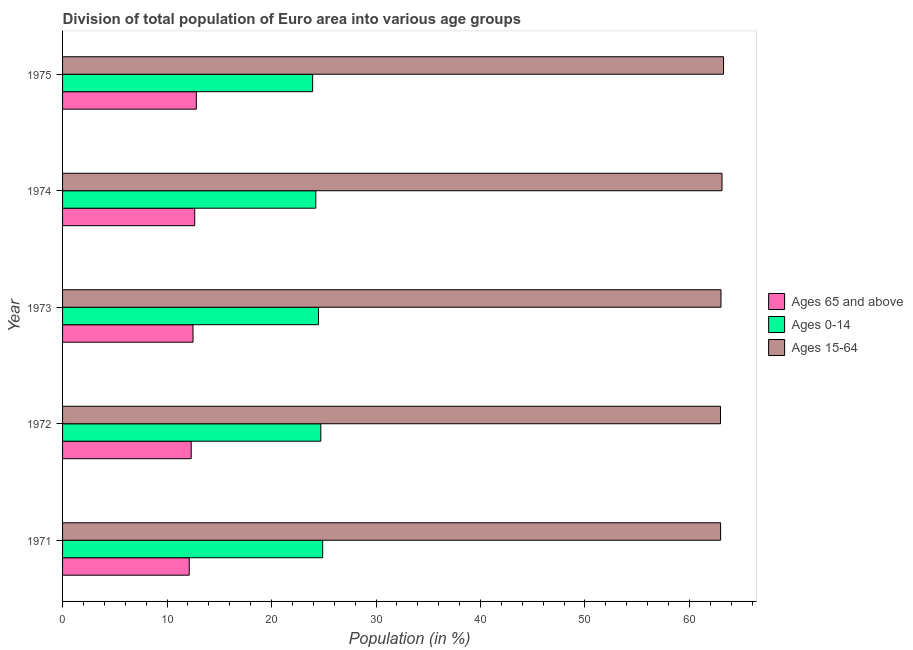How many groups of bars are there?
Ensure brevity in your answer.  5. Are the number of bars per tick equal to the number of legend labels?
Provide a succinct answer. Yes. Are the number of bars on each tick of the Y-axis equal?
Your answer should be very brief. Yes. How many bars are there on the 3rd tick from the bottom?
Your answer should be very brief. 3. What is the label of the 2nd group of bars from the top?
Give a very brief answer. 1974. In how many cases, is the number of bars for a given year not equal to the number of legend labels?
Your answer should be compact. 0. What is the percentage of population within the age-group 0-14 in 1974?
Give a very brief answer. 24.24. Across all years, what is the maximum percentage of population within the age-group 15-64?
Offer a very short reply. 63.26. Across all years, what is the minimum percentage of population within the age-group 0-14?
Make the answer very short. 23.93. In which year was the percentage of population within the age-group 15-64 minimum?
Ensure brevity in your answer.  1972. What is the total percentage of population within the age-group of 65 and above in the graph?
Your response must be concise. 62.37. What is the difference between the percentage of population within the age-group 15-64 in 1972 and that in 1974?
Ensure brevity in your answer.  -0.14. What is the difference between the percentage of population within the age-group 15-64 in 1972 and the percentage of population within the age-group of 65 and above in 1971?
Give a very brief answer. 50.85. What is the average percentage of population within the age-group 0-14 per year?
Offer a terse response. 24.46. In the year 1971, what is the difference between the percentage of population within the age-group 0-14 and percentage of population within the age-group of 65 and above?
Your answer should be very brief. 12.77. What is the ratio of the percentage of population within the age-group of 65 and above in 1973 to that in 1974?
Keep it short and to the point. 0.99. Is the difference between the percentage of population within the age-group 0-14 in 1971 and 1973 greater than the difference between the percentage of population within the age-group 15-64 in 1971 and 1973?
Give a very brief answer. Yes. What is the difference between the highest and the second highest percentage of population within the age-group of 65 and above?
Offer a terse response. 0.15. What is the difference between the highest and the lowest percentage of population within the age-group of 65 and above?
Give a very brief answer. 0.68. In how many years, is the percentage of population within the age-group 15-64 greater than the average percentage of population within the age-group 15-64 taken over all years?
Offer a terse response. 2. What does the 2nd bar from the top in 1974 represents?
Make the answer very short. Ages 0-14. What does the 2nd bar from the bottom in 1971 represents?
Give a very brief answer. Ages 0-14. Is it the case that in every year, the sum of the percentage of population within the age-group of 65 and above and percentage of population within the age-group 0-14 is greater than the percentage of population within the age-group 15-64?
Your answer should be very brief. No. How many years are there in the graph?
Your answer should be very brief. 5. How are the legend labels stacked?
Provide a succinct answer. Vertical. What is the title of the graph?
Ensure brevity in your answer.  Division of total population of Euro area into various age groups
. Does "Taxes on international trade" appear as one of the legend labels in the graph?
Make the answer very short. No. What is the label or title of the Y-axis?
Ensure brevity in your answer.  Year. What is the Population (in %) in Ages 65 and above in 1971?
Your answer should be very brief. 12.12. What is the Population (in %) in Ages 0-14 in 1971?
Provide a succinct answer. 24.9. What is the Population (in %) in Ages 15-64 in 1971?
Your answer should be compact. 62.98. What is the Population (in %) of Ages 65 and above in 1972?
Give a very brief answer. 12.31. What is the Population (in %) of Ages 0-14 in 1972?
Offer a very short reply. 24.72. What is the Population (in %) of Ages 15-64 in 1972?
Offer a very short reply. 62.97. What is the Population (in %) in Ages 65 and above in 1973?
Keep it short and to the point. 12.49. What is the Population (in %) of Ages 0-14 in 1973?
Your answer should be very brief. 24.5. What is the Population (in %) in Ages 15-64 in 1973?
Your answer should be compact. 63.02. What is the Population (in %) in Ages 65 and above in 1974?
Offer a very short reply. 12.65. What is the Population (in %) of Ages 0-14 in 1974?
Provide a succinct answer. 24.24. What is the Population (in %) in Ages 15-64 in 1974?
Ensure brevity in your answer.  63.11. What is the Population (in %) in Ages 65 and above in 1975?
Your answer should be very brief. 12.8. What is the Population (in %) in Ages 0-14 in 1975?
Your response must be concise. 23.93. What is the Population (in %) in Ages 15-64 in 1975?
Make the answer very short. 63.26. Across all years, what is the maximum Population (in %) in Ages 65 and above?
Offer a terse response. 12.8. Across all years, what is the maximum Population (in %) in Ages 0-14?
Provide a succinct answer. 24.9. Across all years, what is the maximum Population (in %) in Ages 15-64?
Ensure brevity in your answer.  63.26. Across all years, what is the minimum Population (in %) in Ages 65 and above?
Your answer should be compact. 12.12. Across all years, what is the minimum Population (in %) of Ages 0-14?
Ensure brevity in your answer.  23.93. Across all years, what is the minimum Population (in %) of Ages 15-64?
Ensure brevity in your answer.  62.97. What is the total Population (in %) of Ages 65 and above in the graph?
Your response must be concise. 62.37. What is the total Population (in %) in Ages 0-14 in the graph?
Your answer should be very brief. 122.28. What is the total Population (in %) of Ages 15-64 in the graph?
Provide a succinct answer. 315.35. What is the difference between the Population (in %) of Ages 65 and above in 1971 and that in 1972?
Offer a very short reply. -0.19. What is the difference between the Population (in %) in Ages 0-14 in 1971 and that in 1972?
Ensure brevity in your answer.  0.18. What is the difference between the Population (in %) in Ages 15-64 in 1971 and that in 1972?
Your response must be concise. 0.01. What is the difference between the Population (in %) in Ages 65 and above in 1971 and that in 1973?
Ensure brevity in your answer.  -0.36. What is the difference between the Population (in %) of Ages 0-14 in 1971 and that in 1973?
Provide a short and direct response. 0.4. What is the difference between the Population (in %) in Ages 15-64 in 1971 and that in 1973?
Ensure brevity in your answer.  -0.04. What is the difference between the Population (in %) of Ages 65 and above in 1971 and that in 1974?
Provide a short and direct response. -0.52. What is the difference between the Population (in %) of Ages 0-14 in 1971 and that in 1974?
Keep it short and to the point. 0.66. What is the difference between the Population (in %) in Ages 15-64 in 1971 and that in 1974?
Ensure brevity in your answer.  -0.13. What is the difference between the Population (in %) of Ages 65 and above in 1971 and that in 1975?
Offer a terse response. -0.68. What is the difference between the Population (in %) of Ages 0-14 in 1971 and that in 1975?
Offer a terse response. 0.96. What is the difference between the Population (in %) in Ages 15-64 in 1971 and that in 1975?
Your response must be concise. -0.28. What is the difference between the Population (in %) of Ages 65 and above in 1972 and that in 1973?
Keep it short and to the point. -0.17. What is the difference between the Population (in %) of Ages 0-14 in 1972 and that in 1973?
Ensure brevity in your answer.  0.22. What is the difference between the Population (in %) in Ages 15-64 in 1972 and that in 1973?
Provide a short and direct response. -0.05. What is the difference between the Population (in %) of Ages 65 and above in 1972 and that in 1974?
Offer a terse response. -0.34. What is the difference between the Population (in %) of Ages 0-14 in 1972 and that in 1974?
Your answer should be very brief. 0.48. What is the difference between the Population (in %) in Ages 15-64 in 1972 and that in 1974?
Your answer should be compact. -0.14. What is the difference between the Population (in %) in Ages 65 and above in 1972 and that in 1975?
Provide a short and direct response. -0.49. What is the difference between the Population (in %) of Ages 0-14 in 1972 and that in 1975?
Your response must be concise. 0.78. What is the difference between the Population (in %) in Ages 15-64 in 1972 and that in 1975?
Provide a succinct answer. -0.29. What is the difference between the Population (in %) in Ages 65 and above in 1973 and that in 1974?
Your response must be concise. -0.16. What is the difference between the Population (in %) in Ages 0-14 in 1973 and that in 1974?
Offer a terse response. 0.26. What is the difference between the Population (in %) of Ages 15-64 in 1973 and that in 1974?
Ensure brevity in your answer.  -0.1. What is the difference between the Population (in %) in Ages 65 and above in 1973 and that in 1975?
Your answer should be compact. -0.32. What is the difference between the Population (in %) in Ages 0-14 in 1973 and that in 1975?
Offer a terse response. 0.56. What is the difference between the Population (in %) of Ages 15-64 in 1973 and that in 1975?
Give a very brief answer. -0.25. What is the difference between the Population (in %) in Ages 65 and above in 1974 and that in 1975?
Provide a succinct answer. -0.15. What is the difference between the Population (in %) in Ages 0-14 in 1974 and that in 1975?
Offer a terse response. 0.3. What is the difference between the Population (in %) of Ages 15-64 in 1974 and that in 1975?
Keep it short and to the point. -0.15. What is the difference between the Population (in %) of Ages 65 and above in 1971 and the Population (in %) of Ages 0-14 in 1972?
Give a very brief answer. -12.59. What is the difference between the Population (in %) of Ages 65 and above in 1971 and the Population (in %) of Ages 15-64 in 1972?
Provide a short and direct response. -50.85. What is the difference between the Population (in %) of Ages 0-14 in 1971 and the Population (in %) of Ages 15-64 in 1972?
Provide a succinct answer. -38.08. What is the difference between the Population (in %) in Ages 65 and above in 1971 and the Population (in %) in Ages 0-14 in 1973?
Make the answer very short. -12.37. What is the difference between the Population (in %) of Ages 65 and above in 1971 and the Population (in %) of Ages 15-64 in 1973?
Keep it short and to the point. -50.89. What is the difference between the Population (in %) in Ages 0-14 in 1971 and the Population (in %) in Ages 15-64 in 1973?
Make the answer very short. -38.12. What is the difference between the Population (in %) of Ages 65 and above in 1971 and the Population (in %) of Ages 0-14 in 1974?
Your response must be concise. -12.11. What is the difference between the Population (in %) in Ages 65 and above in 1971 and the Population (in %) in Ages 15-64 in 1974?
Your answer should be very brief. -50.99. What is the difference between the Population (in %) of Ages 0-14 in 1971 and the Population (in %) of Ages 15-64 in 1974?
Ensure brevity in your answer.  -38.22. What is the difference between the Population (in %) of Ages 65 and above in 1971 and the Population (in %) of Ages 0-14 in 1975?
Ensure brevity in your answer.  -11.81. What is the difference between the Population (in %) of Ages 65 and above in 1971 and the Population (in %) of Ages 15-64 in 1975?
Make the answer very short. -51.14. What is the difference between the Population (in %) in Ages 0-14 in 1971 and the Population (in %) in Ages 15-64 in 1975?
Provide a succinct answer. -38.37. What is the difference between the Population (in %) in Ages 65 and above in 1972 and the Population (in %) in Ages 0-14 in 1973?
Offer a terse response. -12.19. What is the difference between the Population (in %) in Ages 65 and above in 1972 and the Population (in %) in Ages 15-64 in 1973?
Ensure brevity in your answer.  -50.7. What is the difference between the Population (in %) in Ages 0-14 in 1972 and the Population (in %) in Ages 15-64 in 1973?
Make the answer very short. -38.3. What is the difference between the Population (in %) in Ages 65 and above in 1972 and the Population (in %) in Ages 0-14 in 1974?
Provide a short and direct response. -11.93. What is the difference between the Population (in %) of Ages 65 and above in 1972 and the Population (in %) of Ages 15-64 in 1974?
Your answer should be compact. -50.8. What is the difference between the Population (in %) of Ages 0-14 in 1972 and the Population (in %) of Ages 15-64 in 1974?
Give a very brief answer. -38.4. What is the difference between the Population (in %) of Ages 65 and above in 1972 and the Population (in %) of Ages 0-14 in 1975?
Give a very brief answer. -11.62. What is the difference between the Population (in %) of Ages 65 and above in 1972 and the Population (in %) of Ages 15-64 in 1975?
Provide a succinct answer. -50.95. What is the difference between the Population (in %) of Ages 0-14 in 1972 and the Population (in %) of Ages 15-64 in 1975?
Ensure brevity in your answer.  -38.55. What is the difference between the Population (in %) in Ages 65 and above in 1973 and the Population (in %) in Ages 0-14 in 1974?
Provide a short and direct response. -11.75. What is the difference between the Population (in %) of Ages 65 and above in 1973 and the Population (in %) of Ages 15-64 in 1974?
Keep it short and to the point. -50.63. What is the difference between the Population (in %) of Ages 0-14 in 1973 and the Population (in %) of Ages 15-64 in 1974?
Keep it short and to the point. -38.62. What is the difference between the Population (in %) in Ages 65 and above in 1973 and the Population (in %) in Ages 0-14 in 1975?
Ensure brevity in your answer.  -11.45. What is the difference between the Population (in %) in Ages 65 and above in 1973 and the Population (in %) in Ages 15-64 in 1975?
Offer a very short reply. -50.78. What is the difference between the Population (in %) of Ages 0-14 in 1973 and the Population (in %) of Ages 15-64 in 1975?
Your answer should be compact. -38.77. What is the difference between the Population (in %) of Ages 65 and above in 1974 and the Population (in %) of Ages 0-14 in 1975?
Ensure brevity in your answer.  -11.29. What is the difference between the Population (in %) of Ages 65 and above in 1974 and the Population (in %) of Ages 15-64 in 1975?
Provide a short and direct response. -50.62. What is the difference between the Population (in %) in Ages 0-14 in 1974 and the Population (in %) in Ages 15-64 in 1975?
Offer a terse response. -39.03. What is the average Population (in %) in Ages 65 and above per year?
Keep it short and to the point. 12.47. What is the average Population (in %) of Ages 0-14 per year?
Keep it short and to the point. 24.46. What is the average Population (in %) in Ages 15-64 per year?
Your response must be concise. 63.07. In the year 1971, what is the difference between the Population (in %) in Ages 65 and above and Population (in %) in Ages 0-14?
Your answer should be compact. -12.77. In the year 1971, what is the difference between the Population (in %) of Ages 65 and above and Population (in %) of Ages 15-64?
Your answer should be very brief. -50.86. In the year 1971, what is the difference between the Population (in %) of Ages 0-14 and Population (in %) of Ages 15-64?
Your response must be concise. -38.08. In the year 1972, what is the difference between the Population (in %) in Ages 65 and above and Population (in %) in Ages 0-14?
Your answer should be compact. -12.4. In the year 1972, what is the difference between the Population (in %) of Ages 65 and above and Population (in %) of Ages 15-64?
Offer a terse response. -50.66. In the year 1972, what is the difference between the Population (in %) of Ages 0-14 and Population (in %) of Ages 15-64?
Keep it short and to the point. -38.26. In the year 1973, what is the difference between the Population (in %) of Ages 65 and above and Population (in %) of Ages 0-14?
Provide a succinct answer. -12.01. In the year 1973, what is the difference between the Population (in %) in Ages 65 and above and Population (in %) in Ages 15-64?
Make the answer very short. -50.53. In the year 1973, what is the difference between the Population (in %) in Ages 0-14 and Population (in %) in Ages 15-64?
Make the answer very short. -38.52. In the year 1974, what is the difference between the Population (in %) of Ages 65 and above and Population (in %) of Ages 0-14?
Offer a very short reply. -11.59. In the year 1974, what is the difference between the Population (in %) of Ages 65 and above and Population (in %) of Ages 15-64?
Ensure brevity in your answer.  -50.47. In the year 1974, what is the difference between the Population (in %) of Ages 0-14 and Population (in %) of Ages 15-64?
Your answer should be compact. -38.88. In the year 1975, what is the difference between the Population (in %) in Ages 65 and above and Population (in %) in Ages 0-14?
Offer a terse response. -11.13. In the year 1975, what is the difference between the Population (in %) in Ages 65 and above and Population (in %) in Ages 15-64?
Ensure brevity in your answer.  -50.46. In the year 1975, what is the difference between the Population (in %) of Ages 0-14 and Population (in %) of Ages 15-64?
Make the answer very short. -39.33. What is the ratio of the Population (in %) of Ages 65 and above in 1971 to that in 1972?
Offer a terse response. 0.98. What is the ratio of the Population (in %) in Ages 0-14 in 1971 to that in 1972?
Offer a very short reply. 1.01. What is the ratio of the Population (in %) of Ages 15-64 in 1971 to that in 1972?
Provide a short and direct response. 1. What is the ratio of the Population (in %) of Ages 65 and above in 1971 to that in 1973?
Keep it short and to the point. 0.97. What is the ratio of the Population (in %) in Ages 0-14 in 1971 to that in 1973?
Ensure brevity in your answer.  1.02. What is the ratio of the Population (in %) of Ages 15-64 in 1971 to that in 1973?
Ensure brevity in your answer.  1. What is the ratio of the Population (in %) in Ages 65 and above in 1971 to that in 1974?
Keep it short and to the point. 0.96. What is the ratio of the Population (in %) of Ages 0-14 in 1971 to that in 1974?
Make the answer very short. 1.03. What is the ratio of the Population (in %) in Ages 65 and above in 1971 to that in 1975?
Make the answer very short. 0.95. What is the ratio of the Population (in %) of Ages 0-14 in 1971 to that in 1975?
Offer a terse response. 1.04. What is the ratio of the Population (in %) in Ages 15-64 in 1971 to that in 1975?
Your answer should be very brief. 1. What is the ratio of the Population (in %) in Ages 65 and above in 1972 to that in 1973?
Give a very brief answer. 0.99. What is the ratio of the Population (in %) of Ages 0-14 in 1972 to that in 1973?
Ensure brevity in your answer.  1.01. What is the ratio of the Population (in %) of Ages 15-64 in 1972 to that in 1973?
Offer a very short reply. 1. What is the ratio of the Population (in %) in Ages 65 and above in 1972 to that in 1974?
Your answer should be very brief. 0.97. What is the ratio of the Population (in %) of Ages 0-14 in 1972 to that in 1974?
Provide a short and direct response. 1.02. What is the ratio of the Population (in %) of Ages 65 and above in 1972 to that in 1975?
Provide a short and direct response. 0.96. What is the ratio of the Population (in %) of Ages 0-14 in 1972 to that in 1975?
Your answer should be very brief. 1.03. What is the ratio of the Population (in %) of Ages 65 and above in 1973 to that in 1974?
Keep it short and to the point. 0.99. What is the ratio of the Population (in %) of Ages 0-14 in 1973 to that in 1974?
Offer a terse response. 1.01. What is the ratio of the Population (in %) of Ages 15-64 in 1973 to that in 1974?
Make the answer very short. 1. What is the ratio of the Population (in %) of Ages 65 and above in 1973 to that in 1975?
Keep it short and to the point. 0.98. What is the ratio of the Population (in %) in Ages 0-14 in 1973 to that in 1975?
Give a very brief answer. 1.02. What is the ratio of the Population (in %) in Ages 15-64 in 1973 to that in 1975?
Provide a short and direct response. 1. What is the ratio of the Population (in %) in Ages 65 and above in 1974 to that in 1975?
Make the answer very short. 0.99. What is the ratio of the Population (in %) of Ages 0-14 in 1974 to that in 1975?
Keep it short and to the point. 1.01. What is the difference between the highest and the second highest Population (in %) of Ages 65 and above?
Make the answer very short. 0.15. What is the difference between the highest and the second highest Population (in %) of Ages 0-14?
Your response must be concise. 0.18. What is the difference between the highest and the second highest Population (in %) in Ages 15-64?
Your answer should be compact. 0.15. What is the difference between the highest and the lowest Population (in %) of Ages 65 and above?
Give a very brief answer. 0.68. What is the difference between the highest and the lowest Population (in %) of Ages 0-14?
Provide a short and direct response. 0.96. What is the difference between the highest and the lowest Population (in %) in Ages 15-64?
Ensure brevity in your answer.  0.29. 